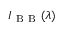Convert formula to latex. <formula><loc_0><loc_0><loc_500><loc_500>I _ { B B } ( \lambda )</formula> 